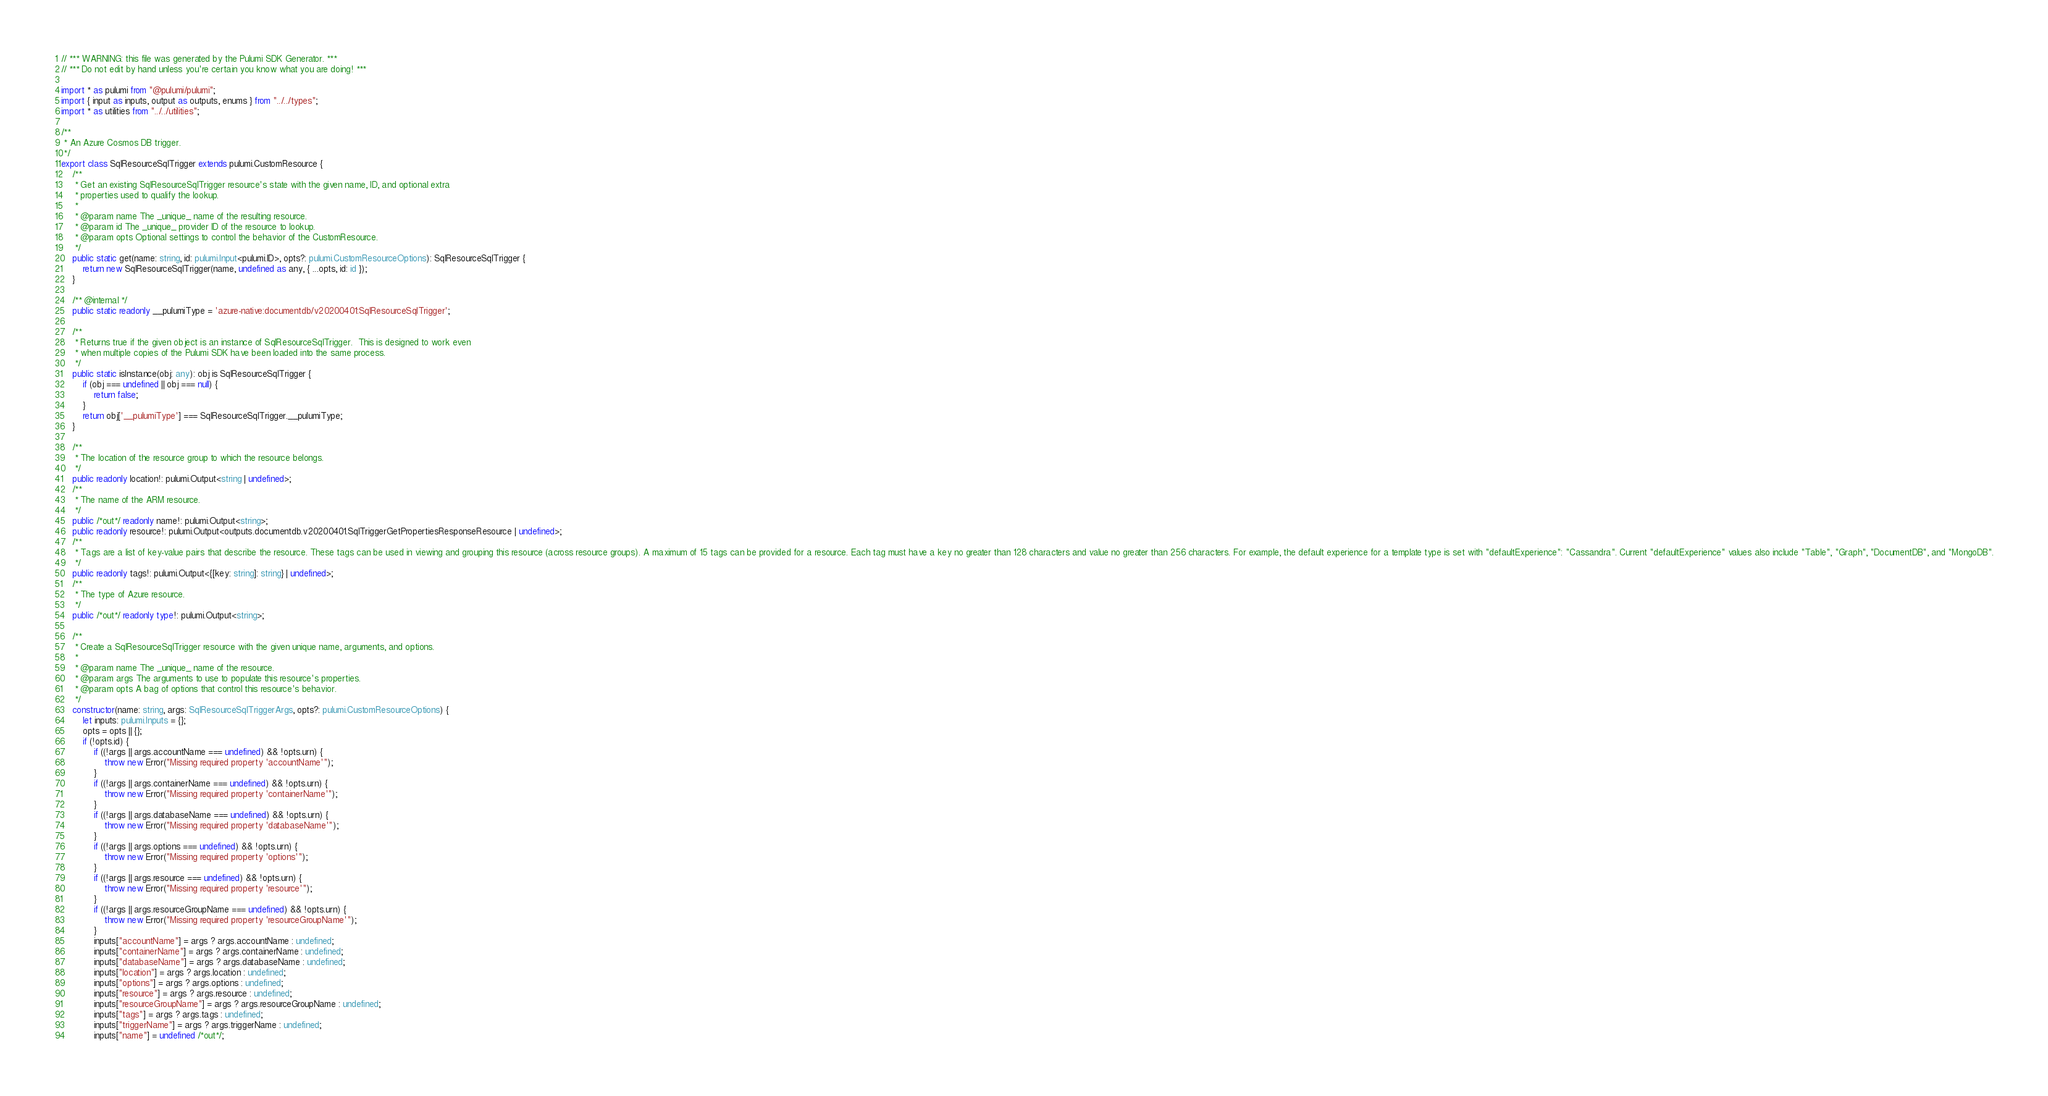<code> <loc_0><loc_0><loc_500><loc_500><_TypeScript_>// *** WARNING: this file was generated by the Pulumi SDK Generator. ***
// *** Do not edit by hand unless you're certain you know what you are doing! ***

import * as pulumi from "@pulumi/pulumi";
import { input as inputs, output as outputs, enums } from "../../types";
import * as utilities from "../../utilities";

/**
 * An Azure Cosmos DB trigger.
 */
export class SqlResourceSqlTrigger extends pulumi.CustomResource {
    /**
     * Get an existing SqlResourceSqlTrigger resource's state with the given name, ID, and optional extra
     * properties used to qualify the lookup.
     *
     * @param name The _unique_ name of the resulting resource.
     * @param id The _unique_ provider ID of the resource to lookup.
     * @param opts Optional settings to control the behavior of the CustomResource.
     */
    public static get(name: string, id: pulumi.Input<pulumi.ID>, opts?: pulumi.CustomResourceOptions): SqlResourceSqlTrigger {
        return new SqlResourceSqlTrigger(name, undefined as any, { ...opts, id: id });
    }

    /** @internal */
    public static readonly __pulumiType = 'azure-native:documentdb/v20200401:SqlResourceSqlTrigger';

    /**
     * Returns true if the given object is an instance of SqlResourceSqlTrigger.  This is designed to work even
     * when multiple copies of the Pulumi SDK have been loaded into the same process.
     */
    public static isInstance(obj: any): obj is SqlResourceSqlTrigger {
        if (obj === undefined || obj === null) {
            return false;
        }
        return obj['__pulumiType'] === SqlResourceSqlTrigger.__pulumiType;
    }

    /**
     * The location of the resource group to which the resource belongs.
     */
    public readonly location!: pulumi.Output<string | undefined>;
    /**
     * The name of the ARM resource.
     */
    public /*out*/ readonly name!: pulumi.Output<string>;
    public readonly resource!: pulumi.Output<outputs.documentdb.v20200401.SqlTriggerGetPropertiesResponseResource | undefined>;
    /**
     * Tags are a list of key-value pairs that describe the resource. These tags can be used in viewing and grouping this resource (across resource groups). A maximum of 15 tags can be provided for a resource. Each tag must have a key no greater than 128 characters and value no greater than 256 characters. For example, the default experience for a template type is set with "defaultExperience": "Cassandra". Current "defaultExperience" values also include "Table", "Graph", "DocumentDB", and "MongoDB".
     */
    public readonly tags!: pulumi.Output<{[key: string]: string} | undefined>;
    /**
     * The type of Azure resource.
     */
    public /*out*/ readonly type!: pulumi.Output<string>;

    /**
     * Create a SqlResourceSqlTrigger resource with the given unique name, arguments, and options.
     *
     * @param name The _unique_ name of the resource.
     * @param args The arguments to use to populate this resource's properties.
     * @param opts A bag of options that control this resource's behavior.
     */
    constructor(name: string, args: SqlResourceSqlTriggerArgs, opts?: pulumi.CustomResourceOptions) {
        let inputs: pulumi.Inputs = {};
        opts = opts || {};
        if (!opts.id) {
            if ((!args || args.accountName === undefined) && !opts.urn) {
                throw new Error("Missing required property 'accountName'");
            }
            if ((!args || args.containerName === undefined) && !opts.urn) {
                throw new Error("Missing required property 'containerName'");
            }
            if ((!args || args.databaseName === undefined) && !opts.urn) {
                throw new Error("Missing required property 'databaseName'");
            }
            if ((!args || args.options === undefined) && !opts.urn) {
                throw new Error("Missing required property 'options'");
            }
            if ((!args || args.resource === undefined) && !opts.urn) {
                throw new Error("Missing required property 'resource'");
            }
            if ((!args || args.resourceGroupName === undefined) && !opts.urn) {
                throw new Error("Missing required property 'resourceGroupName'");
            }
            inputs["accountName"] = args ? args.accountName : undefined;
            inputs["containerName"] = args ? args.containerName : undefined;
            inputs["databaseName"] = args ? args.databaseName : undefined;
            inputs["location"] = args ? args.location : undefined;
            inputs["options"] = args ? args.options : undefined;
            inputs["resource"] = args ? args.resource : undefined;
            inputs["resourceGroupName"] = args ? args.resourceGroupName : undefined;
            inputs["tags"] = args ? args.tags : undefined;
            inputs["triggerName"] = args ? args.triggerName : undefined;
            inputs["name"] = undefined /*out*/;</code> 